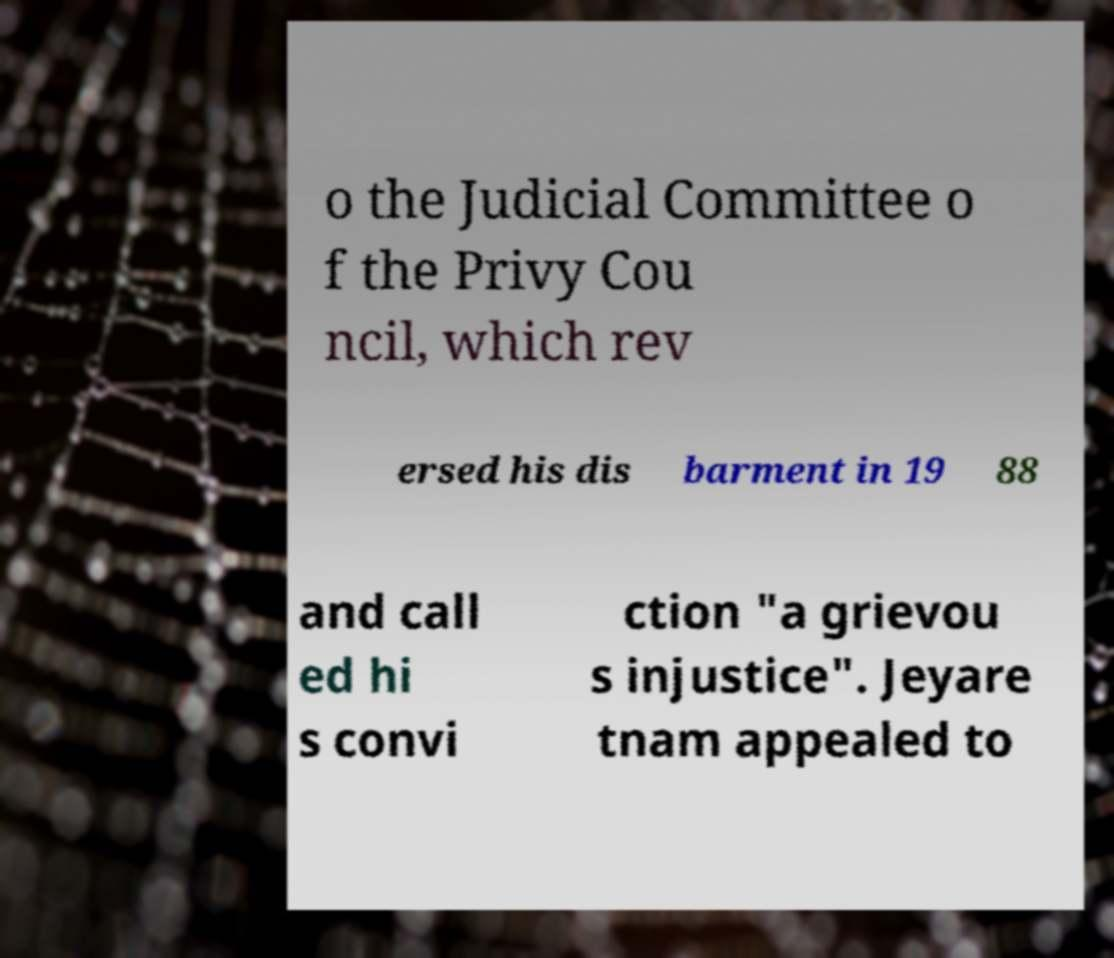Can you read and provide the text displayed in the image?This photo seems to have some interesting text. Can you extract and type it out for me? o the Judicial Committee o f the Privy Cou ncil, which rev ersed his dis barment in 19 88 and call ed hi s convi ction "a grievou s injustice". Jeyare tnam appealed to 